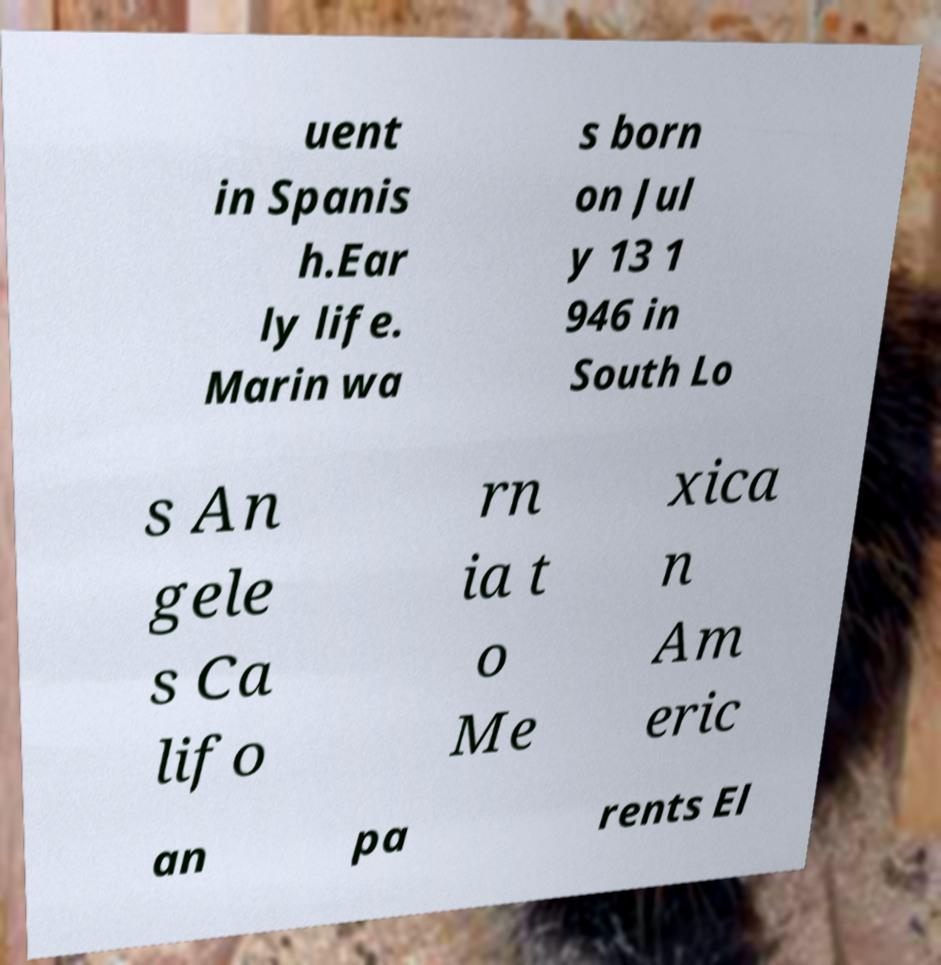I need the written content from this picture converted into text. Can you do that? uent in Spanis h.Ear ly life. Marin wa s born on Jul y 13 1 946 in South Lo s An gele s Ca lifo rn ia t o Me xica n Am eric an pa rents El 